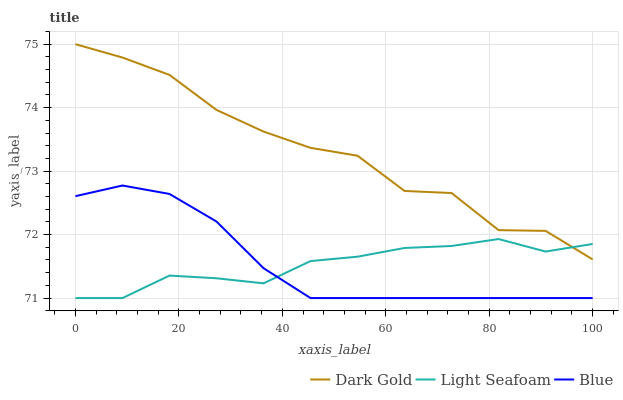Does Light Seafoam have the minimum area under the curve?
Answer yes or no. Yes. Does Dark Gold have the maximum area under the curve?
Answer yes or no. Yes. Does Dark Gold have the minimum area under the curve?
Answer yes or no. No. Does Light Seafoam have the maximum area under the curve?
Answer yes or no. No. Is Blue the smoothest?
Answer yes or no. Yes. Is Dark Gold the roughest?
Answer yes or no. Yes. Is Light Seafoam the smoothest?
Answer yes or no. No. Is Light Seafoam the roughest?
Answer yes or no. No. Does Blue have the lowest value?
Answer yes or no. Yes. Does Dark Gold have the lowest value?
Answer yes or no. No. Does Dark Gold have the highest value?
Answer yes or no. Yes. Does Light Seafoam have the highest value?
Answer yes or no. No. Is Blue less than Dark Gold?
Answer yes or no. Yes. Is Dark Gold greater than Blue?
Answer yes or no. Yes. Does Light Seafoam intersect Dark Gold?
Answer yes or no. Yes. Is Light Seafoam less than Dark Gold?
Answer yes or no. No. Is Light Seafoam greater than Dark Gold?
Answer yes or no. No. Does Blue intersect Dark Gold?
Answer yes or no. No. 